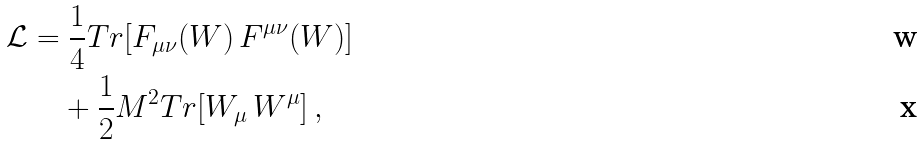<formula> <loc_0><loc_0><loc_500><loc_500>\mathcal { L } & = \frac { 1 } { 4 } T r [ F _ { \mu \nu } ( W ) \, F ^ { \mu \nu } ( W ) ] \\ & \quad + \frac { 1 } { 2 } M ^ { 2 } T r [ W _ { \mu } \, W ^ { \mu } ] \, ,</formula> 